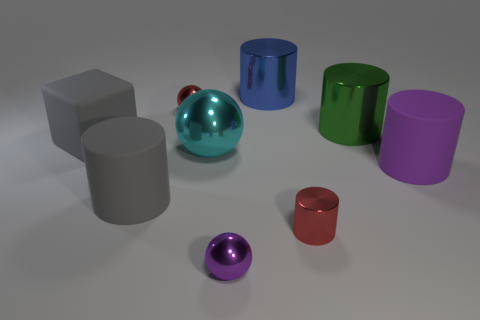Subtract all big cyan metallic balls. How many balls are left? 2 Add 1 big purple cylinders. How many objects exist? 10 Subtract all red spheres. How many spheres are left? 2 Subtract all cubes. How many objects are left? 8 Subtract 1 purple spheres. How many objects are left? 8 Subtract 4 cylinders. How many cylinders are left? 1 Subtract all yellow spheres. Subtract all blue cylinders. How many spheres are left? 3 Subtract all red spheres. How many red cylinders are left? 1 Subtract all purple cylinders. Subtract all big matte blocks. How many objects are left? 7 Add 4 gray cubes. How many gray cubes are left? 5 